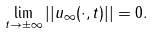<formula> <loc_0><loc_0><loc_500><loc_500>\lim _ { t \rightarrow \pm \infty } | | u _ { \infty } ( \cdot , t ) | | = 0 .</formula> 